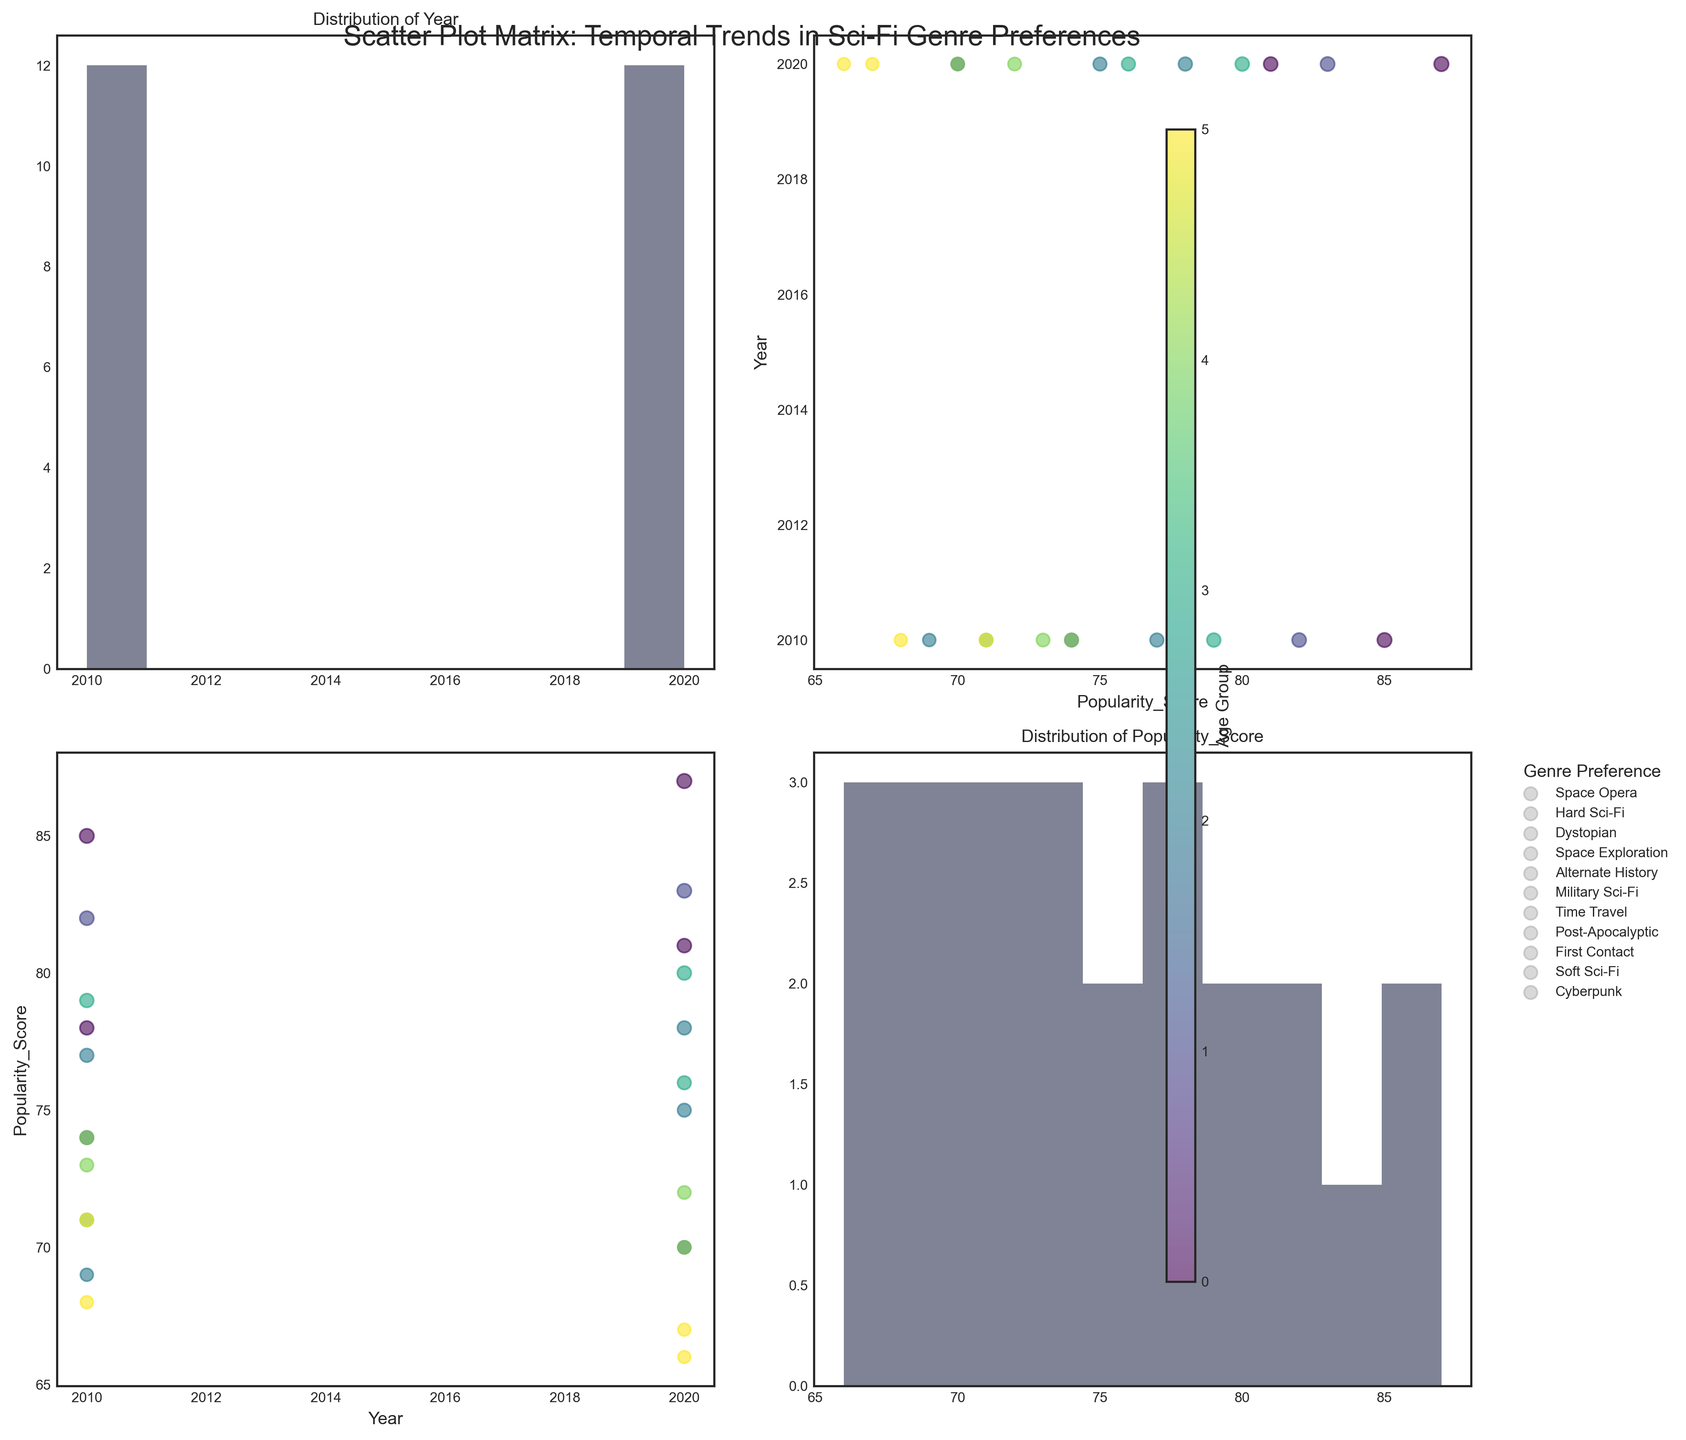How are female readers aged 18-24 represented in the data for the year 2010? Look at the data points for the year 2010 within the age group 18-24 labeled 'Female'. There is one data point, specifically for the genre 'Space Opera' with a popularity score of 78.
Answer: 'Space Opera' with a score of 78 What trend can be observed in the popularity score of Dystopian genre among male readers from 2010 to 2020? Locate the data points for male readers in 2010 and 2020 for the genre 'Dystopian'. In 2010, there is no data for this segment, but in 2020, the popularity score for Dystopian among male readers aged 65+ is 67. This suggests an increase in popularity within that demographic over time.
Answer: Increased to 67 for ages 65+ in 2020 What's the total number of genres preferred by female readers aged 35-44 across both years? Determine the unique genres preferred by female readers aged 35-44 in 2010 and 2020. In 2010, it's 'Alternate History', and in 2020, it's 'Space Opera'. Therefore, the total number of unique genres is two.
Answer: 2 genres Which age group had the highest popularity score for the Hard Sci-Fi genre in 2020? Find the data points for the 'Hard Sci-Fi' genre in 2020. The data point indicates that male readers aged 35-44 had a popularity score of 78, which appears to be the highest for that genre in this year.
Answer: Ages 35-44 How does the popularity score for female readers aged 55-64 in 2020 compare to those in 2010? Compare the data points for female readers aged 55-64 for both years. In 2010, the popularity score is 73 for 'First Contact', while in 2020, it's 70 for 'Alternate History'. This indicates a slight decrease in popularity for this age group.
Answer: Decreased from 73 to 70 